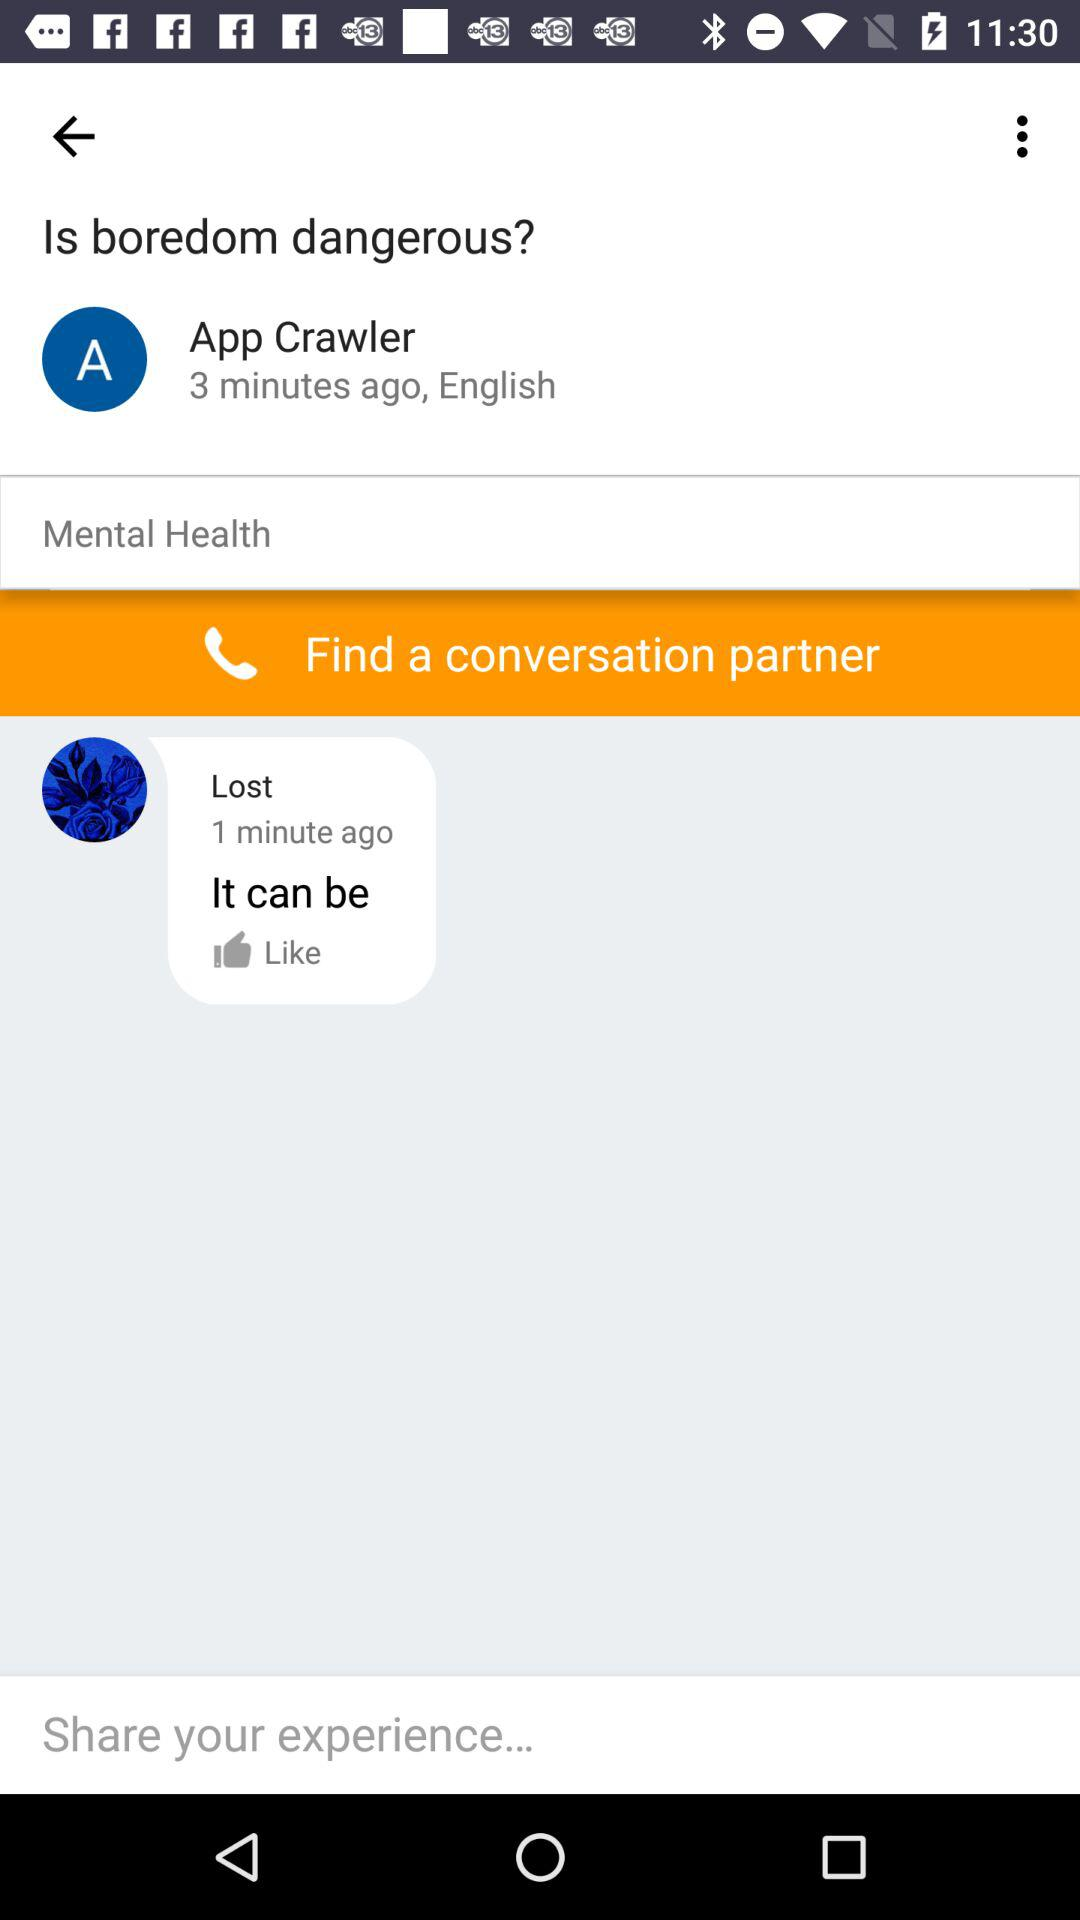When was the post posted? The post was posted 3 minutes ago. 